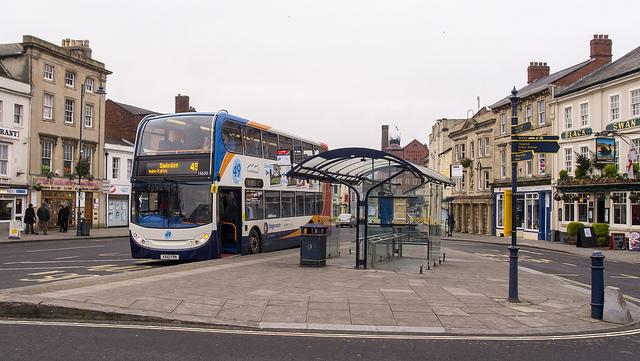What is the round blue bin used to collect? trash 